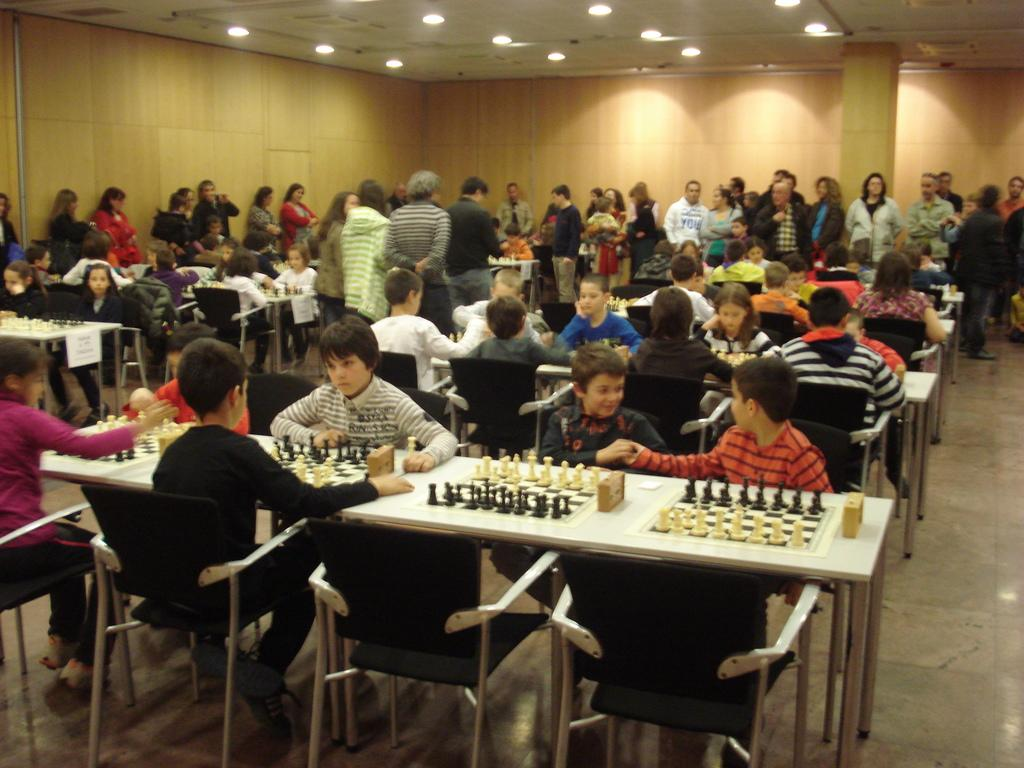What are the people in the image doing? There are people sitting on chairs and standing in the image. What can be seen on the table in the image? There is a chess board with coins and a stop watch on the table. What type of credit can be seen on the plate in the image? There is no plate or credit present in the image. 